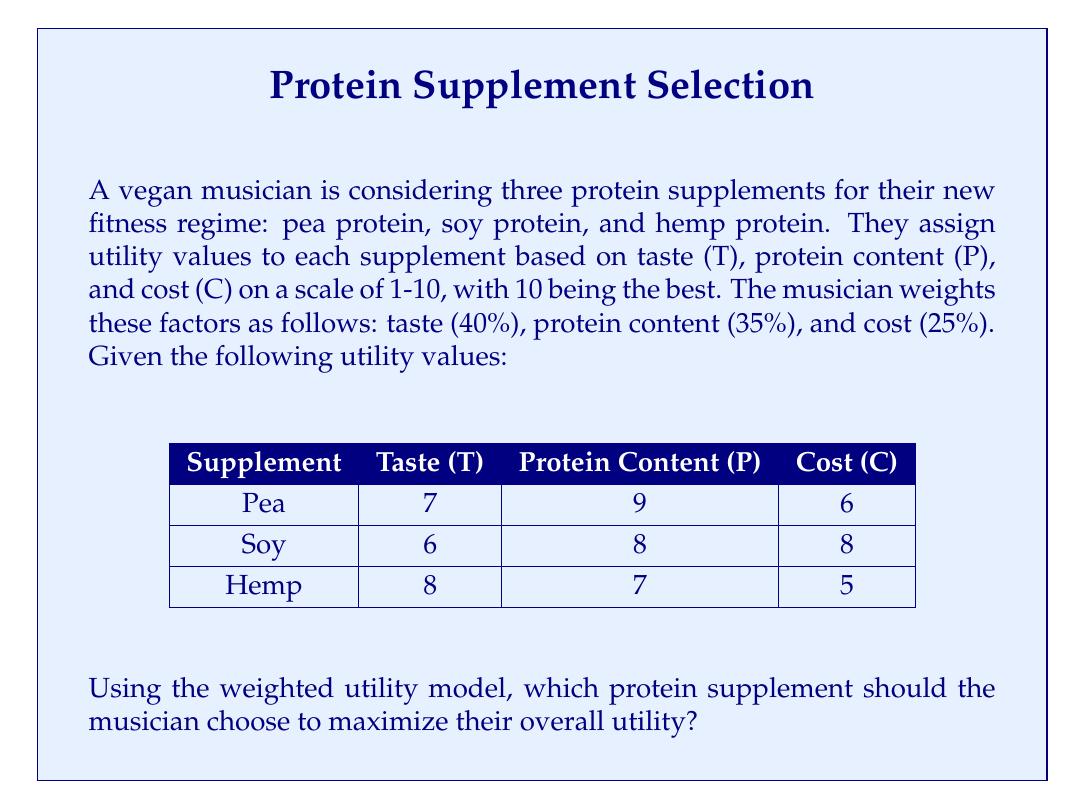What is the answer to this math problem? To solve this problem, we'll use the weighted utility model. The steps are as follows:

1) First, we need to calculate the weighted utility for each supplement using the formula:

   $U = 0.4T + 0.35P + 0.25C$

   Where $U$ is the overall utility, $T$ is the taste score, $P$ is the protein content score, and $C$ is the cost score.

2) Let's calculate for each supplement:

   For Pea Protein:
   $U_{pea} = 0.4(7) + 0.35(9) + 0.25(6)$
   $U_{pea} = 2.8 + 3.15 + 1.5 = 7.45$

   For Soy Protein:
   $U_{soy} = 0.4(6) + 0.35(8) + 0.25(8)$
   $U_{soy} = 2.4 + 2.8 + 2 = 7.2$

   For Hemp Protein:
   $U_{hemp} = 0.4(8) + 0.35(7) + 0.25(5)$
   $U_{hemp} = 3.2 + 2.45 + 1.25 = 6.9$

3) Now, we compare the overall utility scores:

   Pea Protein: 7.45
   Soy Protein: 7.2
   Hemp Protein: 6.9

4) The highest utility score is 7.45, corresponding to the pea protein supplement.

Therefore, to maximize overall utility, the musician should choose the pea protein supplement.
Answer: The musician should choose the pea protein supplement, which has the highest overall utility score of 7.45. 